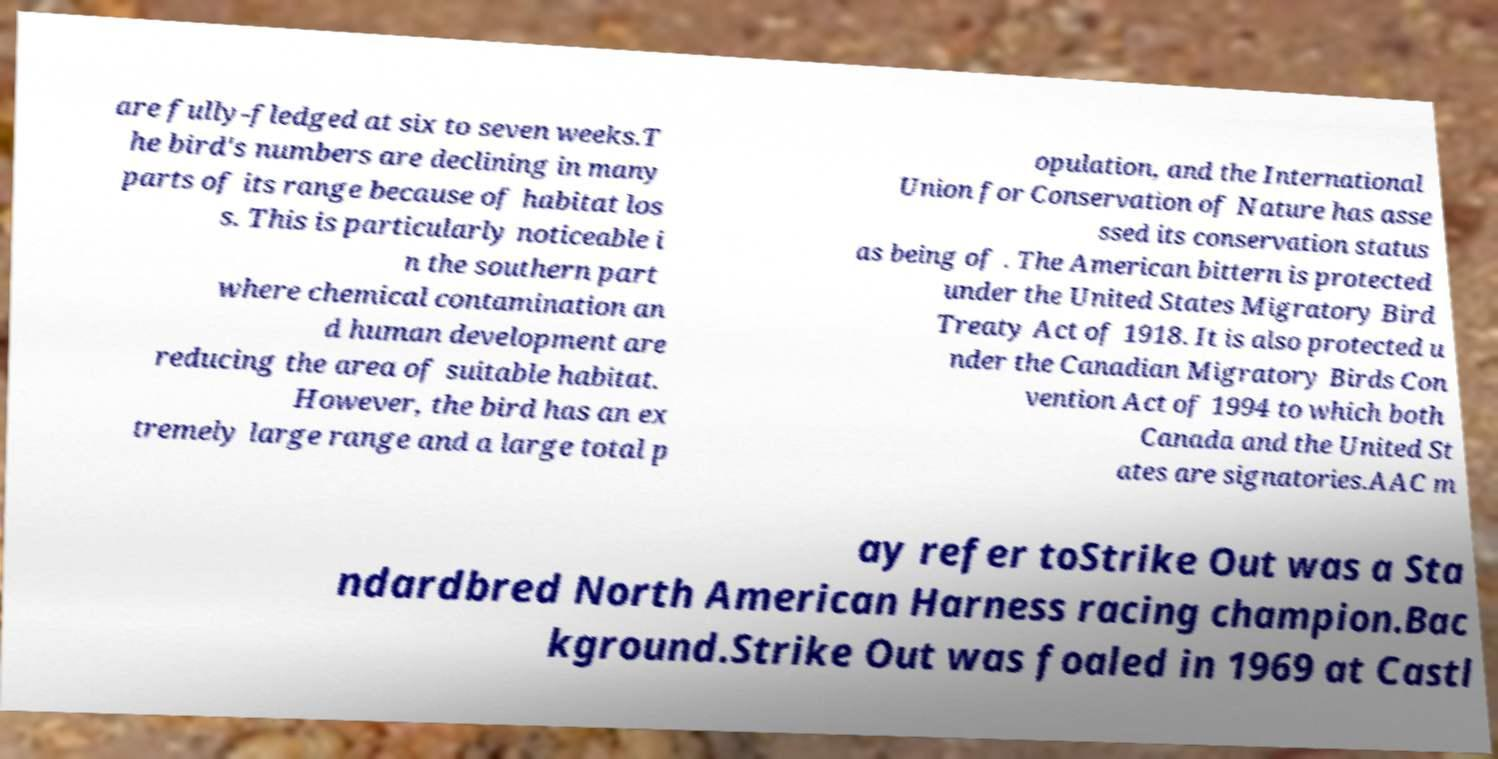What messages or text are displayed in this image? I need them in a readable, typed format. are fully-fledged at six to seven weeks.T he bird's numbers are declining in many parts of its range because of habitat los s. This is particularly noticeable i n the southern part where chemical contamination an d human development are reducing the area of suitable habitat. However, the bird has an ex tremely large range and a large total p opulation, and the International Union for Conservation of Nature has asse ssed its conservation status as being of . The American bittern is protected under the United States Migratory Bird Treaty Act of 1918. It is also protected u nder the Canadian Migratory Birds Con vention Act of 1994 to which both Canada and the United St ates are signatories.AAC m ay refer toStrike Out was a Sta ndardbred North American Harness racing champion.Bac kground.Strike Out was foaled in 1969 at Castl 